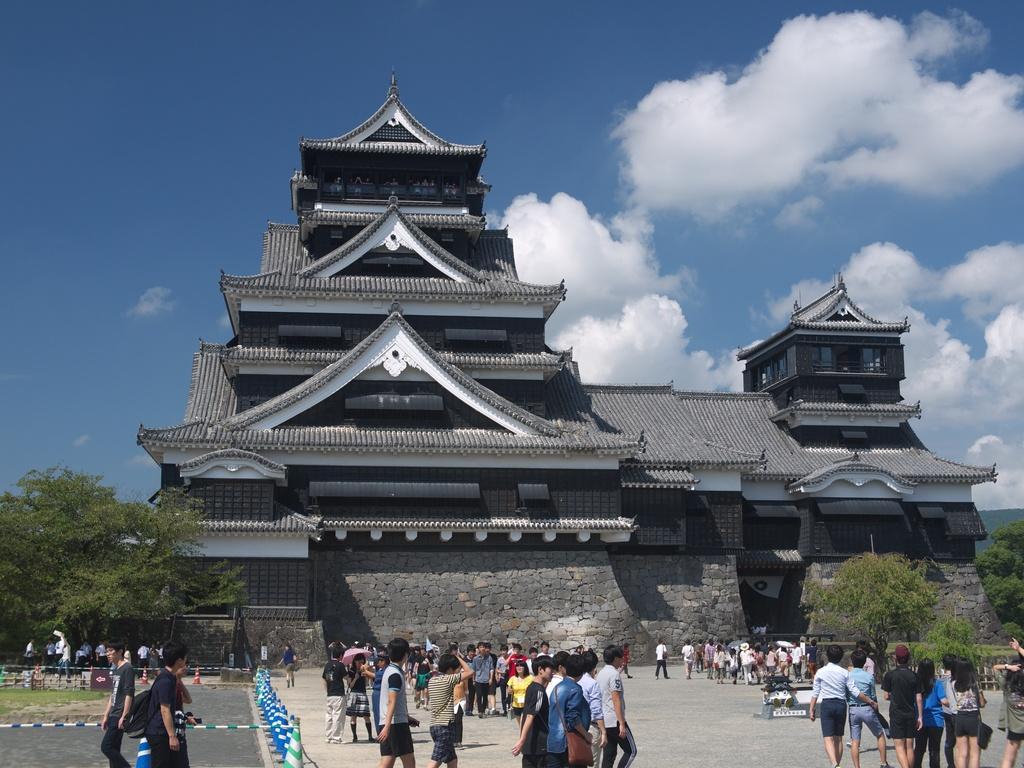In one or two sentences, can you explain what this image depicts? There are people, trees and a building. 